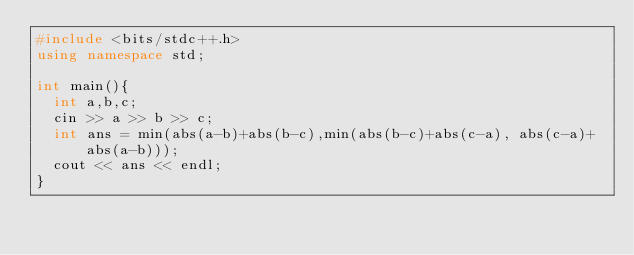Convert code to text. <code><loc_0><loc_0><loc_500><loc_500><_C++_>#include <bits/stdc++.h>
using namespace std;

int main(){
  int a,b,c;
  cin >> a >> b >> c;
  int ans = min(abs(a-b)+abs(b-c),min(abs(b-c)+abs(c-a), abs(c-a)+abs(a-b)));
  cout << ans << endl;
}
</code> 